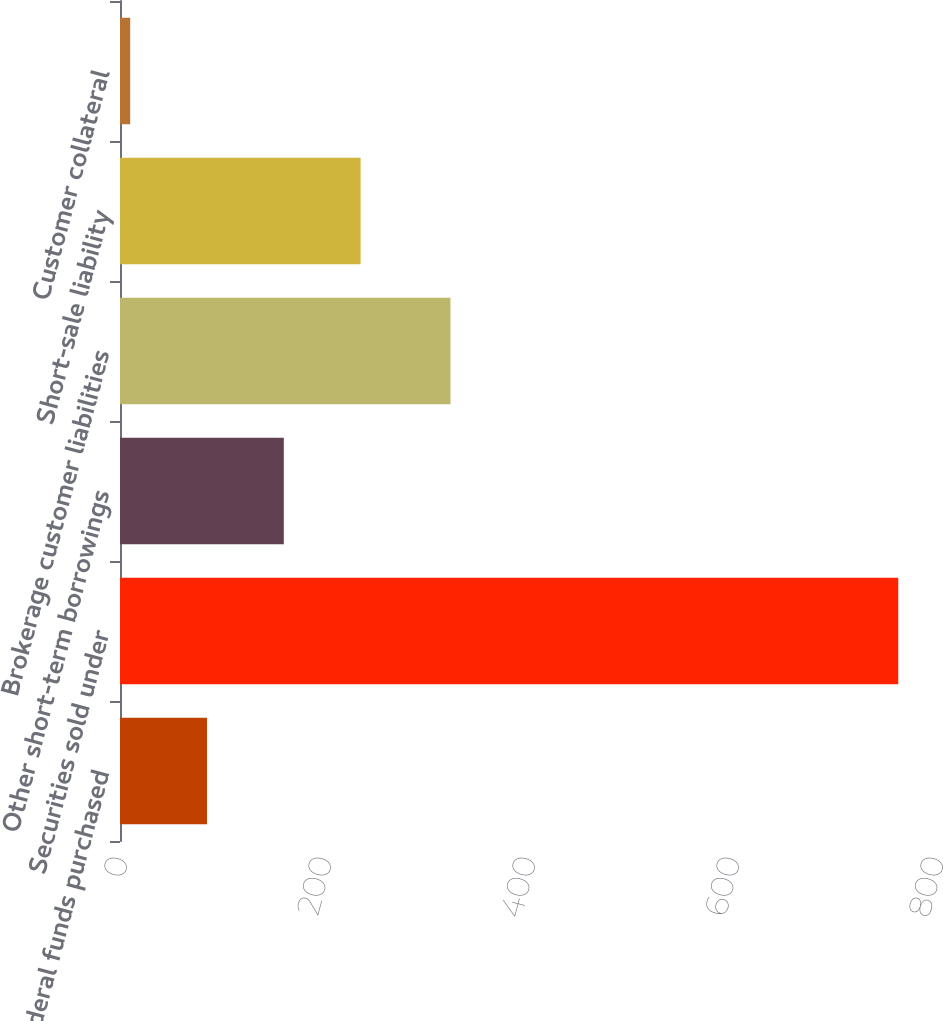<chart> <loc_0><loc_0><loc_500><loc_500><bar_chart><fcel>Federal funds purchased<fcel>Securities sold under<fcel>Other short-term borrowings<fcel>Brokerage customer liabilities<fcel>Short-sale liability<fcel>Customer collateral<nl><fcel>85.3<fcel>763<fcel>160.6<fcel>324<fcel>235.9<fcel>10<nl></chart> 